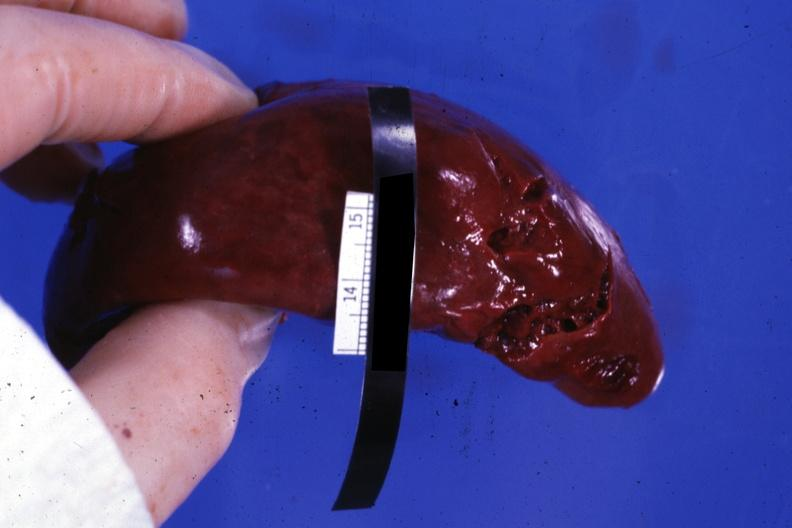does pus in test tube show external view with several tears in capsule?
Answer the question using a single word or phrase. No 